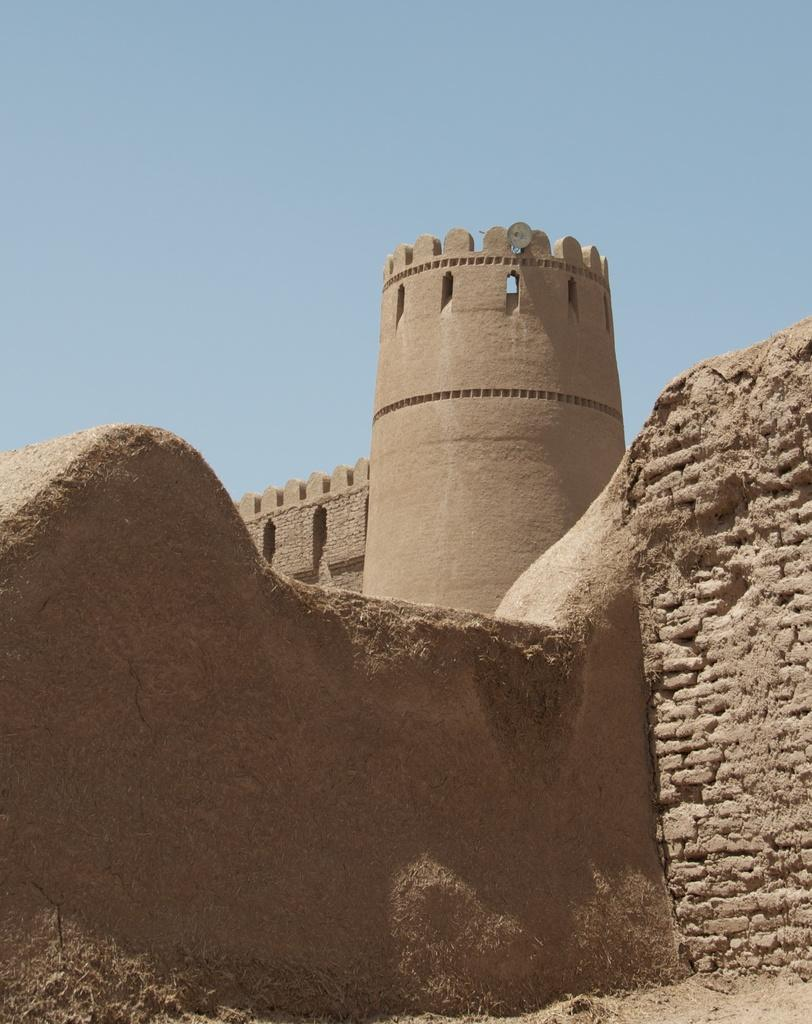What type of structure is present in the image? There is a fort in the image. What is the color of the fort? The fort is brown in color. What materials were used to construct the wall of the fort? The wall in the image is made of soil and stones. What can be seen in the background of the image? The sky is blue in the background of the image. What type of vest is worn by the fort in the image? There is no vest present in the image, as the subject is a fort and not a person. 